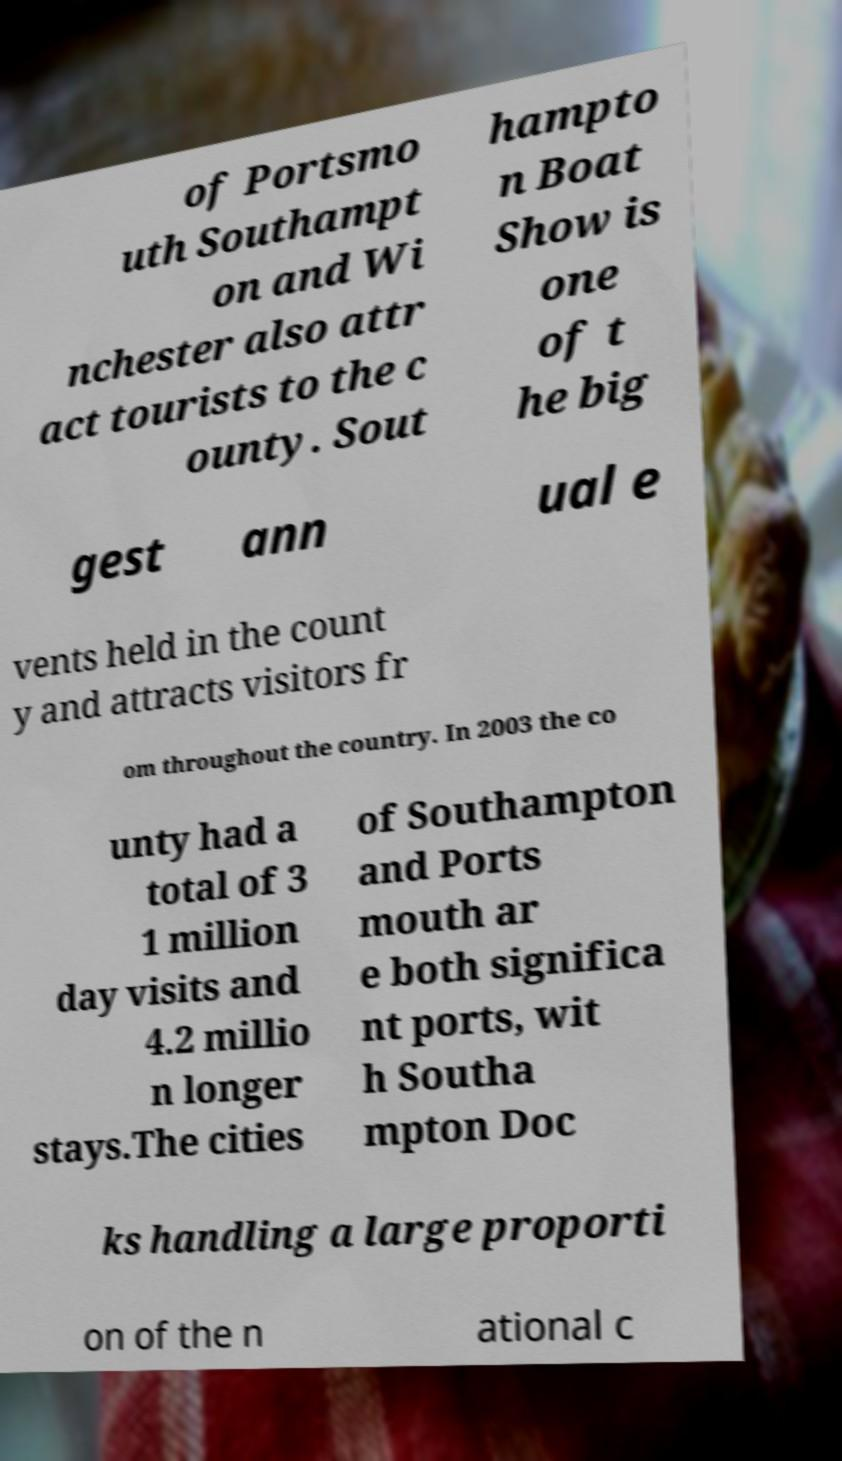For documentation purposes, I need the text within this image transcribed. Could you provide that? of Portsmo uth Southampt on and Wi nchester also attr act tourists to the c ounty. Sout hampto n Boat Show is one of t he big gest ann ual e vents held in the count y and attracts visitors fr om throughout the country. In 2003 the co unty had a total of 3 1 million day visits and 4.2 millio n longer stays.The cities of Southampton and Ports mouth ar e both significa nt ports, wit h Southa mpton Doc ks handling a large proporti on of the n ational c 